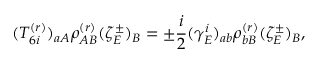<formula> <loc_0><loc_0><loc_500><loc_500>( T _ { 6 i } ^ { ( r ) } ) _ { a A } \rho _ { A B } ^ { ( r ) } ( \zeta _ { E } ^ { \pm } ) _ { B } = \pm \frac { i } { 2 } ( \gamma _ { E } ^ { i } ) _ { a b } \rho _ { b B } ^ { ( r ) } ( \zeta _ { E } ^ { \pm } ) _ { B } ,</formula> 